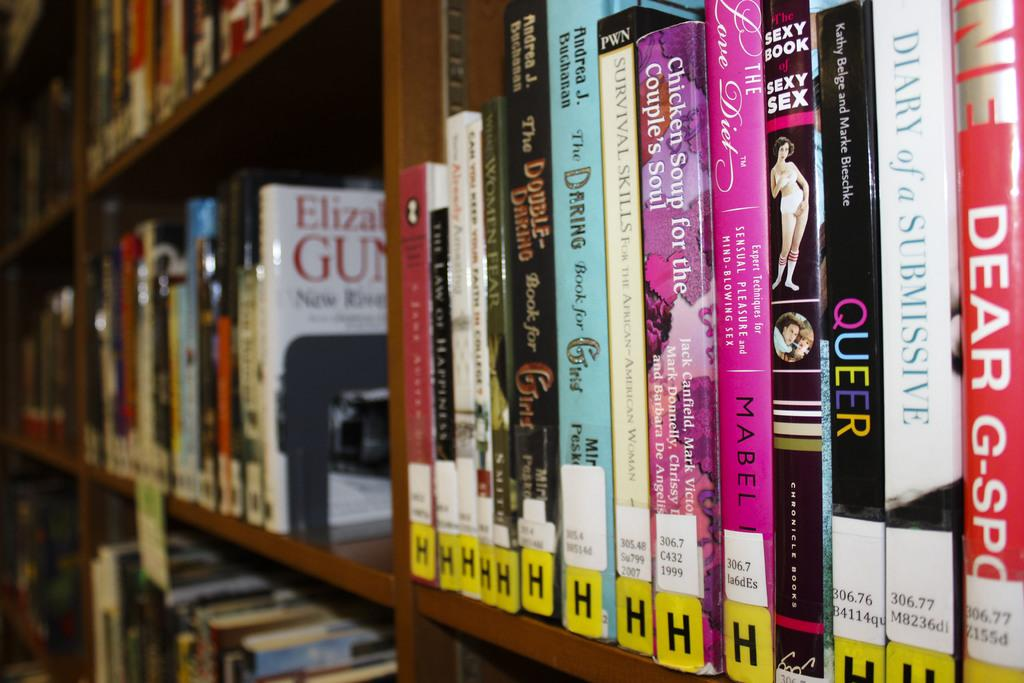<image>
Relay a brief, clear account of the picture shown. Among the book titles on this shelf are Chicken Soup for the Couple's Soul, Dear G-Spot, and Diary of a Submissive. 